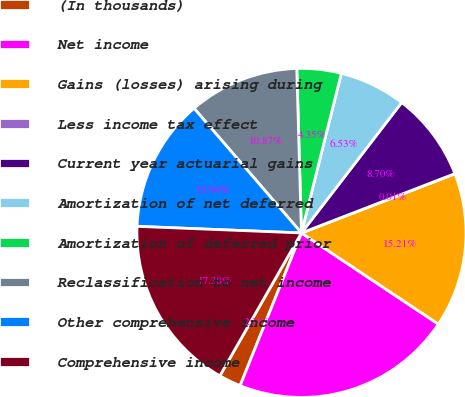Convert chart. <chart><loc_0><loc_0><loc_500><loc_500><pie_chart><fcel>(In thousands)<fcel>Net income<fcel>Gains (losses) arising during<fcel>Less income tax effect<fcel>Current year actuarial gains<fcel>Amortization of net deferred<fcel>Amortization of deferred prior<fcel>Reclassification to net income<fcel>Other comprehensive income<fcel>Comprehensive income<nl><fcel>2.18%<fcel>21.73%<fcel>15.21%<fcel>0.01%<fcel>8.7%<fcel>6.53%<fcel>4.35%<fcel>10.87%<fcel>13.04%<fcel>17.38%<nl></chart> 